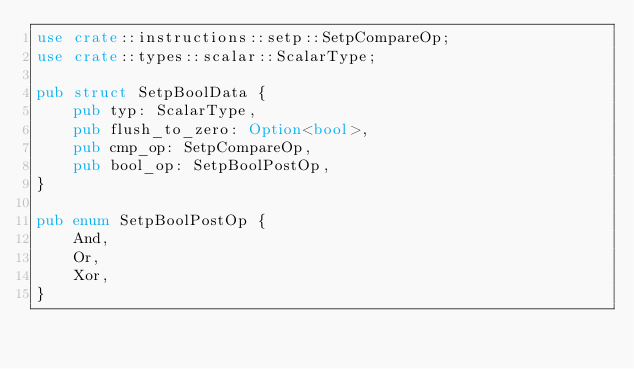Convert code to text. <code><loc_0><loc_0><loc_500><loc_500><_Rust_>use crate::instructions::setp::SetpCompareOp;
use crate::types::scalar::ScalarType;

pub struct SetpBoolData {
    pub typ: ScalarType,
    pub flush_to_zero: Option<bool>,
    pub cmp_op: SetpCompareOp,
    pub bool_op: SetpBoolPostOp,
}

pub enum SetpBoolPostOp {
    And,
    Or,
    Xor,
}


</code> 